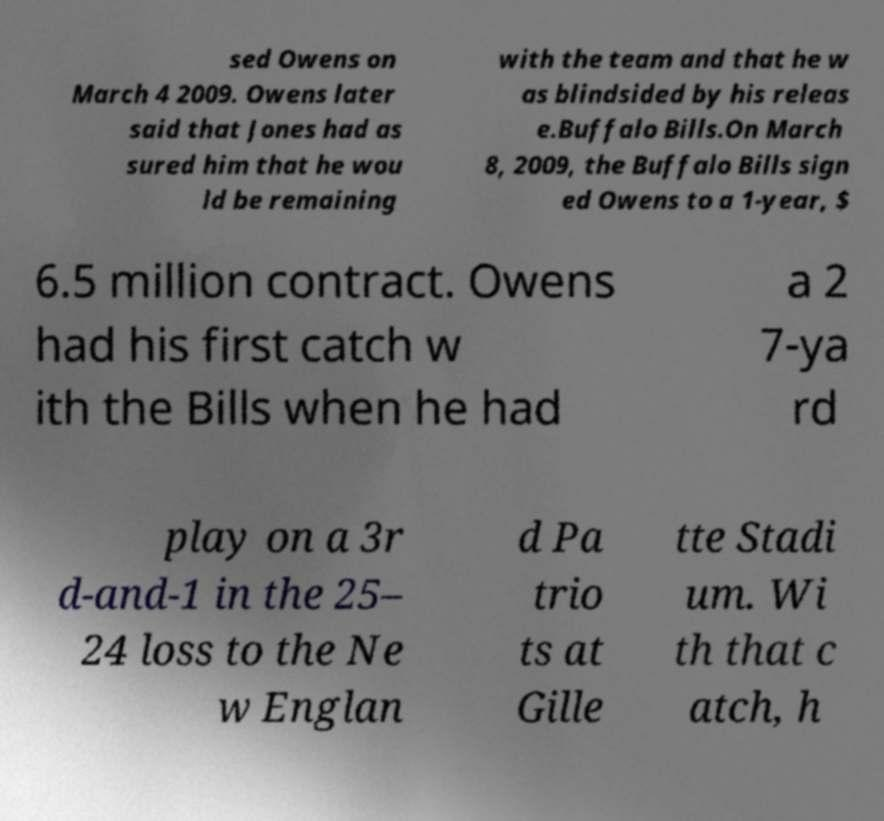I need the written content from this picture converted into text. Can you do that? sed Owens on March 4 2009. Owens later said that Jones had as sured him that he wou ld be remaining with the team and that he w as blindsided by his releas e.Buffalo Bills.On March 8, 2009, the Buffalo Bills sign ed Owens to a 1-year, $ 6.5 million contract. Owens had his first catch w ith the Bills when he had a 2 7-ya rd play on a 3r d-and-1 in the 25– 24 loss to the Ne w Englan d Pa trio ts at Gille tte Stadi um. Wi th that c atch, h 